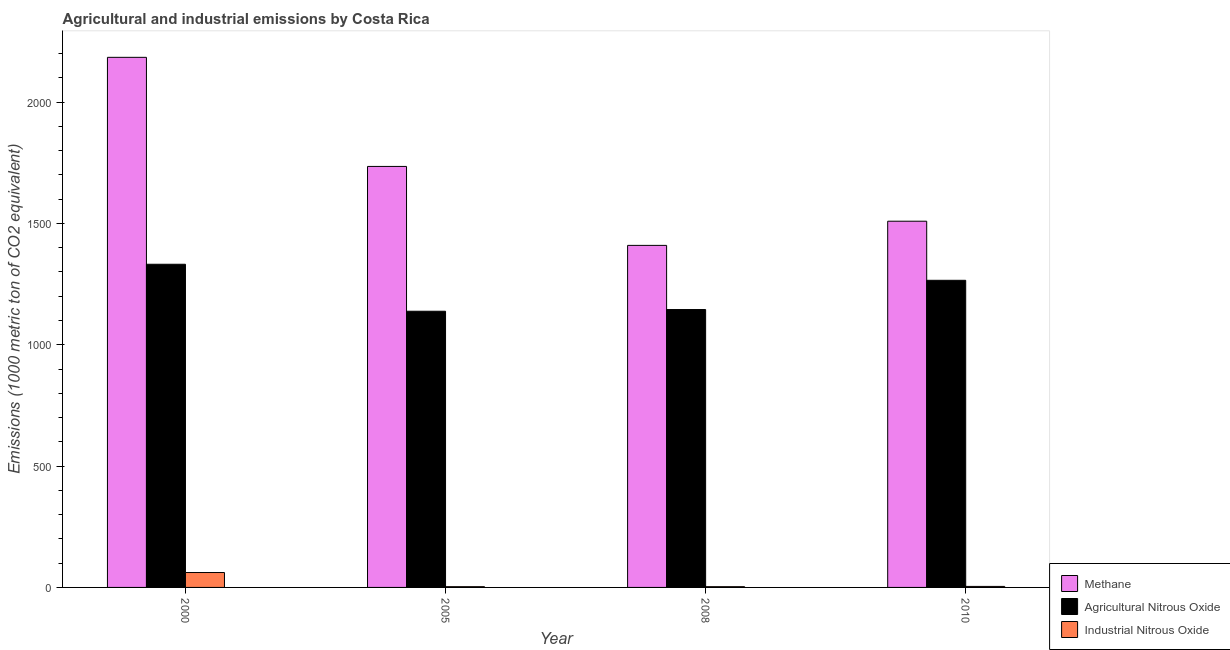How many different coloured bars are there?
Make the answer very short. 3. How many groups of bars are there?
Provide a short and direct response. 4. Are the number of bars per tick equal to the number of legend labels?
Provide a short and direct response. Yes. Are the number of bars on each tick of the X-axis equal?
Offer a very short reply. Yes. How many bars are there on the 2nd tick from the left?
Make the answer very short. 3. How many bars are there on the 1st tick from the right?
Your answer should be compact. 3. What is the label of the 1st group of bars from the left?
Your answer should be very brief. 2000. In how many cases, is the number of bars for a given year not equal to the number of legend labels?
Ensure brevity in your answer.  0. What is the amount of methane emissions in 2008?
Make the answer very short. 1409.6. Across all years, what is the maximum amount of agricultural nitrous oxide emissions?
Offer a very short reply. 1331.8. Across all years, what is the minimum amount of methane emissions?
Your response must be concise. 1409.6. What is the total amount of methane emissions in the graph?
Make the answer very short. 6838.4. What is the difference between the amount of industrial nitrous oxide emissions in 2000 and that in 2005?
Offer a very short reply. 58.3. What is the difference between the amount of industrial nitrous oxide emissions in 2000 and the amount of methane emissions in 2010?
Offer a terse response. 57.2. What is the average amount of methane emissions per year?
Provide a short and direct response. 1709.6. In the year 2005, what is the difference between the amount of agricultural nitrous oxide emissions and amount of industrial nitrous oxide emissions?
Keep it short and to the point. 0. In how many years, is the amount of methane emissions greater than 1100 metric ton?
Provide a succinct answer. 4. What is the ratio of the amount of methane emissions in 2005 to that in 2008?
Your answer should be compact. 1.23. Is the difference between the amount of methane emissions in 2000 and 2008 greater than the difference between the amount of agricultural nitrous oxide emissions in 2000 and 2008?
Your answer should be very brief. No. What is the difference between the highest and the second highest amount of methane emissions?
Your answer should be compact. 449.6. What is the difference between the highest and the lowest amount of industrial nitrous oxide emissions?
Give a very brief answer. 58.3. Is the sum of the amount of agricultural nitrous oxide emissions in 2000 and 2010 greater than the maximum amount of industrial nitrous oxide emissions across all years?
Give a very brief answer. Yes. What does the 2nd bar from the left in 2000 represents?
Keep it short and to the point. Agricultural Nitrous Oxide. What does the 2nd bar from the right in 2000 represents?
Offer a very short reply. Agricultural Nitrous Oxide. How many bars are there?
Your answer should be compact. 12. Are all the bars in the graph horizontal?
Your response must be concise. No. What is the difference between two consecutive major ticks on the Y-axis?
Your answer should be compact. 500. Are the values on the major ticks of Y-axis written in scientific E-notation?
Offer a very short reply. No. Does the graph contain grids?
Make the answer very short. No. Where does the legend appear in the graph?
Provide a succinct answer. Bottom right. How many legend labels are there?
Provide a succinct answer. 3. How are the legend labels stacked?
Give a very brief answer. Vertical. What is the title of the graph?
Your answer should be compact. Agricultural and industrial emissions by Costa Rica. What is the label or title of the Y-axis?
Give a very brief answer. Emissions (1000 metric ton of CO2 equivalent). What is the Emissions (1000 metric ton of CO2 equivalent) of Methane in 2000?
Offer a terse response. 2184.6. What is the Emissions (1000 metric ton of CO2 equivalent) of Agricultural Nitrous Oxide in 2000?
Make the answer very short. 1331.8. What is the Emissions (1000 metric ton of CO2 equivalent) of Industrial Nitrous Oxide in 2000?
Provide a short and direct response. 61.4. What is the Emissions (1000 metric ton of CO2 equivalent) in Methane in 2005?
Your answer should be compact. 1735. What is the Emissions (1000 metric ton of CO2 equivalent) of Agricultural Nitrous Oxide in 2005?
Give a very brief answer. 1138.2. What is the Emissions (1000 metric ton of CO2 equivalent) in Industrial Nitrous Oxide in 2005?
Make the answer very short. 3.1. What is the Emissions (1000 metric ton of CO2 equivalent) in Methane in 2008?
Provide a short and direct response. 1409.6. What is the Emissions (1000 metric ton of CO2 equivalent) of Agricultural Nitrous Oxide in 2008?
Provide a succinct answer. 1145.2. What is the Emissions (1000 metric ton of CO2 equivalent) of Methane in 2010?
Your response must be concise. 1509.2. What is the Emissions (1000 metric ton of CO2 equivalent) of Agricultural Nitrous Oxide in 2010?
Provide a succinct answer. 1265.7. Across all years, what is the maximum Emissions (1000 metric ton of CO2 equivalent) of Methane?
Offer a very short reply. 2184.6. Across all years, what is the maximum Emissions (1000 metric ton of CO2 equivalent) of Agricultural Nitrous Oxide?
Ensure brevity in your answer.  1331.8. Across all years, what is the maximum Emissions (1000 metric ton of CO2 equivalent) of Industrial Nitrous Oxide?
Offer a very short reply. 61.4. Across all years, what is the minimum Emissions (1000 metric ton of CO2 equivalent) in Methane?
Your response must be concise. 1409.6. Across all years, what is the minimum Emissions (1000 metric ton of CO2 equivalent) in Agricultural Nitrous Oxide?
Offer a terse response. 1138.2. What is the total Emissions (1000 metric ton of CO2 equivalent) of Methane in the graph?
Your answer should be very brief. 6838.4. What is the total Emissions (1000 metric ton of CO2 equivalent) in Agricultural Nitrous Oxide in the graph?
Ensure brevity in your answer.  4880.9. What is the total Emissions (1000 metric ton of CO2 equivalent) of Industrial Nitrous Oxide in the graph?
Make the answer very short. 71.8. What is the difference between the Emissions (1000 metric ton of CO2 equivalent) of Methane in 2000 and that in 2005?
Your response must be concise. 449.6. What is the difference between the Emissions (1000 metric ton of CO2 equivalent) of Agricultural Nitrous Oxide in 2000 and that in 2005?
Your answer should be compact. 193.6. What is the difference between the Emissions (1000 metric ton of CO2 equivalent) in Industrial Nitrous Oxide in 2000 and that in 2005?
Your response must be concise. 58.3. What is the difference between the Emissions (1000 metric ton of CO2 equivalent) of Methane in 2000 and that in 2008?
Make the answer very short. 775. What is the difference between the Emissions (1000 metric ton of CO2 equivalent) of Agricultural Nitrous Oxide in 2000 and that in 2008?
Offer a very short reply. 186.6. What is the difference between the Emissions (1000 metric ton of CO2 equivalent) of Industrial Nitrous Oxide in 2000 and that in 2008?
Keep it short and to the point. 58.3. What is the difference between the Emissions (1000 metric ton of CO2 equivalent) in Methane in 2000 and that in 2010?
Offer a terse response. 675.4. What is the difference between the Emissions (1000 metric ton of CO2 equivalent) in Agricultural Nitrous Oxide in 2000 and that in 2010?
Your answer should be compact. 66.1. What is the difference between the Emissions (1000 metric ton of CO2 equivalent) of Industrial Nitrous Oxide in 2000 and that in 2010?
Make the answer very short. 57.2. What is the difference between the Emissions (1000 metric ton of CO2 equivalent) in Methane in 2005 and that in 2008?
Ensure brevity in your answer.  325.4. What is the difference between the Emissions (1000 metric ton of CO2 equivalent) of Industrial Nitrous Oxide in 2005 and that in 2008?
Ensure brevity in your answer.  0. What is the difference between the Emissions (1000 metric ton of CO2 equivalent) in Methane in 2005 and that in 2010?
Your answer should be very brief. 225.8. What is the difference between the Emissions (1000 metric ton of CO2 equivalent) in Agricultural Nitrous Oxide in 2005 and that in 2010?
Your answer should be compact. -127.5. What is the difference between the Emissions (1000 metric ton of CO2 equivalent) of Industrial Nitrous Oxide in 2005 and that in 2010?
Provide a succinct answer. -1.1. What is the difference between the Emissions (1000 metric ton of CO2 equivalent) of Methane in 2008 and that in 2010?
Your answer should be compact. -99.6. What is the difference between the Emissions (1000 metric ton of CO2 equivalent) of Agricultural Nitrous Oxide in 2008 and that in 2010?
Offer a terse response. -120.5. What is the difference between the Emissions (1000 metric ton of CO2 equivalent) of Methane in 2000 and the Emissions (1000 metric ton of CO2 equivalent) of Agricultural Nitrous Oxide in 2005?
Offer a terse response. 1046.4. What is the difference between the Emissions (1000 metric ton of CO2 equivalent) of Methane in 2000 and the Emissions (1000 metric ton of CO2 equivalent) of Industrial Nitrous Oxide in 2005?
Provide a short and direct response. 2181.5. What is the difference between the Emissions (1000 metric ton of CO2 equivalent) in Agricultural Nitrous Oxide in 2000 and the Emissions (1000 metric ton of CO2 equivalent) in Industrial Nitrous Oxide in 2005?
Offer a terse response. 1328.7. What is the difference between the Emissions (1000 metric ton of CO2 equivalent) of Methane in 2000 and the Emissions (1000 metric ton of CO2 equivalent) of Agricultural Nitrous Oxide in 2008?
Offer a terse response. 1039.4. What is the difference between the Emissions (1000 metric ton of CO2 equivalent) of Methane in 2000 and the Emissions (1000 metric ton of CO2 equivalent) of Industrial Nitrous Oxide in 2008?
Make the answer very short. 2181.5. What is the difference between the Emissions (1000 metric ton of CO2 equivalent) of Agricultural Nitrous Oxide in 2000 and the Emissions (1000 metric ton of CO2 equivalent) of Industrial Nitrous Oxide in 2008?
Ensure brevity in your answer.  1328.7. What is the difference between the Emissions (1000 metric ton of CO2 equivalent) in Methane in 2000 and the Emissions (1000 metric ton of CO2 equivalent) in Agricultural Nitrous Oxide in 2010?
Offer a terse response. 918.9. What is the difference between the Emissions (1000 metric ton of CO2 equivalent) in Methane in 2000 and the Emissions (1000 metric ton of CO2 equivalent) in Industrial Nitrous Oxide in 2010?
Your answer should be very brief. 2180.4. What is the difference between the Emissions (1000 metric ton of CO2 equivalent) in Agricultural Nitrous Oxide in 2000 and the Emissions (1000 metric ton of CO2 equivalent) in Industrial Nitrous Oxide in 2010?
Your response must be concise. 1327.6. What is the difference between the Emissions (1000 metric ton of CO2 equivalent) in Methane in 2005 and the Emissions (1000 metric ton of CO2 equivalent) in Agricultural Nitrous Oxide in 2008?
Your response must be concise. 589.8. What is the difference between the Emissions (1000 metric ton of CO2 equivalent) of Methane in 2005 and the Emissions (1000 metric ton of CO2 equivalent) of Industrial Nitrous Oxide in 2008?
Provide a short and direct response. 1731.9. What is the difference between the Emissions (1000 metric ton of CO2 equivalent) in Agricultural Nitrous Oxide in 2005 and the Emissions (1000 metric ton of CO2 equivalent) in Industrial Nitrous Oxide in 2008?
Your answer should be compact. 1135.1. What is the difference between the Emissions (1000 metric ton of CO2 equivalent) of Methane in 2005 and the Emissions (1000 metric ton of CO2 equivalent) of Agricultural Nitrous Oxide in 2010?
Keep it short and to the point. 469.3. What is the difference between the Emissions (1000 metric ton of CO2 equivalent) in Methane in 2005 and the Emissions (1000 metric ton of CO2 equivalent) in Industrial Nitrous Oxide in 2010?
Offer a terse response. 1730.8. What is the difference between the Emissions (1000 metric ton of CO2 equivalent) in Agricultural Nitrous Oxide in 2005 and the Emissions (1000 metric ton of CO2 equivalent) in Industrial Nitrous Oxide in 2010?
Make the answer very short. 1134. What is the difference between the Emissions (1000 metric ton of CO2 equivalent) in Methane in 2008 and the Emissions (1000 metric ton of CO2 equivalent) in Agricultural Nitrous Oxide in 2010?
Provide a succinct answer. 143.9. What is the difference between the Emissions (1000 metric ton of CO2 equivalent) of Methane in 2008 and the Emissions (1000 metric ton of CO2 equivalent) of Industrial Nitrous Oxide in 2010?
Keep it short and to the point. 1405.4. What is the difference between the Emissions (1000 metric ton of CO2 equivalent) in Agricultural Nitrous Oxide in 2008 and the Emissions (1000 metric ton of CO2 equivalent) in Industrial Nitrous Oxide in 2010?
Your response must be concise. 1141. What is the average Emissions (1000 metric ton of CO2 equivalent) of Methane per year?
Provide a succinct answer. 1709.6. What is the average Emissions (1000 metric ton of CO2 equivalent) of Agricultural Nitrous Oxide per year?
Offer a terse response. 1220.22. What is the average Emissions (1000 metric ton of CO2 equivalent) in Industrial Nitrous Oxide per year?
Make the answer very short. 17.95. In the year 2000, what is the difference between the Emissions (1000 metric ton of CO2 equivalent) of Methane and Emissions (1000 metric ton of CO2 equivalent) of Agricultural Nitrous Oxide?
Keep it short and to the point. 852.8. In the year 2000, what is the difference between the Emissions (1000 metric ton of CO2 equivalent) of Methane and Emissions (1000 metric ton of CO2 equivalent) of Industrial Nitrous Oxide?
Your answer should be compact. 2123.2. In the year 2000, what is the difference between the Emissions (1000 metric ton of CO2 equivalent) in Agricultural Nitrous Oxide and Emissions (1000 metric ton of CO2 equivalent) in Industrial Nitrous Oxide?
Keep it short and to the point. 1270.4. In the year 2005, what is the difference between the Emissions (1000 metric ton of CO2 equivalent) in Methane and Emissions (1000 metric ton of CO2 equivalent) in Agricultural Nitrous Oxide?
Offer a very short reply. 596.8. In the year 2005, what is the difference between the Emissions (1000 metric ton of CO2 equivalent) of Methane and Emissions (1000 metric ton of CO2 equivalent) of Industrial Nitrous Oxide?
Offer a terse response. 1731.9. In the year 2005, what is the difference between the Emissions (1000 metric ton of CO2 equivalent) of Agricultural Nitrous Oxide and Emissions (1000 metric ton of CO2 equivalent) of Industrial Nitrous Oxide?
Your response must be concise. 1135.1. In the year 2008, what is the difference between the Emissions (1000 metric ton of CO2 equivalent) in Methane and Emissions (1000 metric ton of CO2 equivalent) in Agricultural Nitrous Oxide?
Your answer should be very brief. 264.4. In the year 2008, what is the difference between the Emissions (1000 metric ton of CO2 equivalent) in Methane and Emissions (1000 metric ton of CO2 equivalent) in Industrial Nitrous Oxide?
Your answer should be very brief. 1406.5. In the year 2008, what is the difference between the Emissions (1000 metric ton of CO2 equivalent) in Agricultural Nitrous Oxide and Emissions (1000 metric ton of CO2 equivalent) in Industrial Nitrous Oxide?
Offer a terse response. 1142.1. In the year 2010, what is the difference between the Emissions (1000 metric ton of CO2 equivalent) of Methane and Emissions (1000 metric ton of CO2 equivalent) of Agricultural Nitrous Oxide?
Provide a short and direct response. 243.5. In the year 2010, what is the difference between the Emissions (1000 metric ton of CO2 equivalent) of Methane and Emissions (1000 metric ton of CO2 equivalent) of Industrial Nitrous Oxide?
Ensure brevity in your answer.  1505. In the year 2010, what is the difference between the Emissions (1000 metric ton of CO2 equivalent) in Agricultural Nitrous Oxide and Emissions (1000 metric ton of CO2 equivalent) in Industrial Nitrous Oxide?
Offer a very short reply. 1261.5. What is the ratio of the Emissions (1000 metric ton of CO2 equivalent) of Methane in 2000 to that in 2005?
Your response must be concise. 1.26. What is the ratio of the Emissions (1000 metric ton of CO2 equivalent) in Agricultural Nitrous Oxide in 2000 to that in 2005?
Offer a terse response. 1.17. What is the ratio of the Emissions (1000 metric ton of CO2 equivalent) of Industrial Nitrous Oxide in 2000 to that in 2005?
Provide a succinct answer. 19.81. What is the ratio of the Emissions (1000 metric ton of CO2 equivalent) in Methane in 2000 to that in 2008?
Your answer should be compact. 1.55. What is the ratio of the Emissions (1000 metric ton of CO2 equivalent) of Agricultural Nitrous Oxide in 2000 to that in 2008?
Make the answer very short. 1.16. What is the ratio of the Emissions (1000 metric ton of CO2 equivalent) in Industrial Nitrous Oxide in 2000 to that in 2008?
Your answer should be very brief. 19.81. What is the ratio of the Emissions (1000 metric ton of CO2 equivalent) in Methane in 2000 to that in 2010?
Keep it short and to the point. 1.45. What is the ratio of the Emissions (1000 metric ton of CO2 equivalent) of Agricultural Nitrous Oxide in 2000 to that in 2010?
Your answer should be very brief. 1.05. What is the ratio of the Emissions (1000 metric ton of CO2 equivalent) in Industrial Nitrous Oxide in 2000 to that in 2010?
Ensure brevity in your answer.  14.62. What is the ratio of the Emissions (1000 metric ton of CO2 equivalent) of Methane in 2005 to that in 2008?
Provide a short and direct response. 1.23. What is the ratio of the Emissions (1000 metric ton of CO2 equivalent) of Methane in 2005 to that in 2010?
Keep it short and to the point. 1.15. What is the ratio of the Emissions (1000 metric ton of CO2 equivalent) of Agricultural Nitrous Oxide in 2005 to that in 2010?
Your response must be concise. 0.9. What is the ratio of the Emissions (1000 metric ton of CO2 equivalent) in Industrial Nitrous Oxide in 2005 to that in 2010?
Offer a very short reply. 0.74. What is the ratio of the Emissions (1000 metric ton of CO2 equivalent) of Methane in 2008 to that in 2010?
Offer a terse response. 0.93. What is the ratio of the Emissions (1000 metric ton of CO2 equivalent) of Agricultural Nitrous Oxide in 2008 to that in 2010?
Give a very brief answer. 0.9. What is the ratio of the Emissions (1000 metric ton of CO2 equivalent) in Industrial Nitrous Oxide in 2008 to that in 2010?
Provide a short and direct response. 0.74. What is the difference between the highest and the second highest Emissions (1000 metric ton of CO2 equivalent) in Methane?
Make the answer very short. 449.6. What is the difference between the highest and the second highest Emissions (1000 metric ton of CO2 equivalent) of Agricultural Nitrous Oxide?
Provide a succinct answer. 66.1. What is the difference between the highest and the second highest Emissions (1000 metric ton of CO2 equivalent) in Industrial Nitrous Oxide?
Provide a short and direct response. 57.2. What is the difference between the highest and the lowest Emissions (1000 metric ton of CO2 equivalent) of Methane?
Provide a succinct answer. 775. What is the difference between the highest and the lowest Emissions (1000 metric ton of CO2 equivalent) in Agricultural Nitrous Oxide?
Make the answer very short. 193.6. What is the difference between the highest and the lowest Emissions (1000 metric ton of CO2 equivalent) in Industrial Nitrous Oxide?
Your response must be concise. 58.3. 